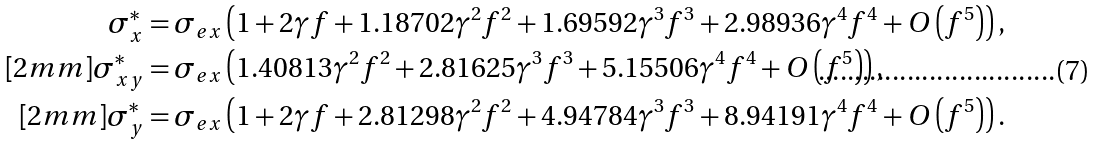<formula> <loc_0><loc_0><loc_500><loc_500>\sigma _ { x } ^ { \ast } & = \sigma _ { e x } \left ( 1 + 2 \gamma f + 1 . 1 8 7 0 2 \gamma ^ { 2 } f ^ { 2 } + 1 . 6 9 5 9 2 \gamma ^ { 3 } f ^ { 3 } + 2 . 9 8 9 3 6 \gamma ^ { 4 } f ^ { 4 } + O \left ( f ^ { 5 } \right ) \right ) , \\ [ 2 m m ] \sigma _ { x y } ^ { \ast } & = \sigma _ { e x } \left ( 1 . 4 0 8 1 3 \gamma ^ { 2 } f ^ { 2 } + 2 . 8 1 6 2 5 \gamma ^ { 3 } f ^ { 3 } + 5 . 1 5 5 0 6 \gamma ^ { 4 } f ^ { 4 } + O \left ( f ^ { 5 } \right ) \right ) , \\ [ 2 m m ] \sigma _ { y } ^ { \ast } & = \sigma _ { e x } \left ( 1 + 2 \gamma f + 2 . 8 1 2 9 8 \gamma ^ { 2 } f ^ { 2 } + 4 . 9 4 7 8 4 \gamma ^ { 3 } f ^ { 3 } + 8 . 9 4 1 9 1 \gamma ^ { 4 } f ^ { 4 } + O \left ( f ^ { 5 } \right ) \right ) .</formula> 